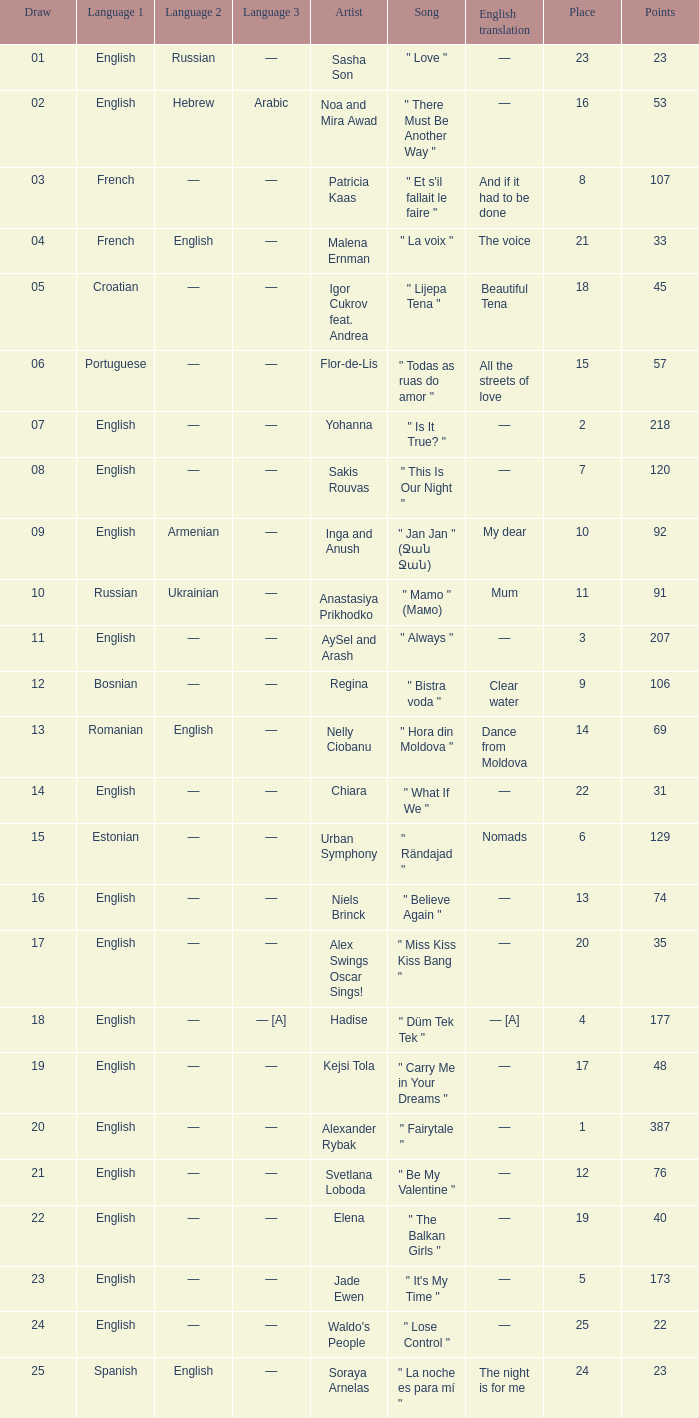What was the english translation for the song by svetlana loboda? —. 